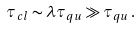<formula> <loc_0><loc_0><loc_500><loc_500>\tau _ { c l } \sim \lambda \tau _ { q u } \gg \tau _ { q u } \, .</formula> 